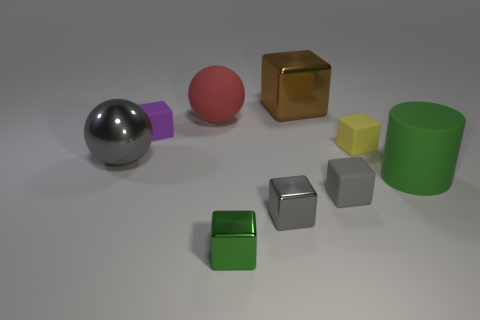Imagine these objects were used in a game, what kind of game could it be? These geometric objects could be used in an educational puzzle game where players must sort or match them based on their shapes, colors, or materials. Alternatively, they could serve as pieces in a strategy game, with different shapes representing different roles or powers, similar to how chess pieces move and interact on a board. 